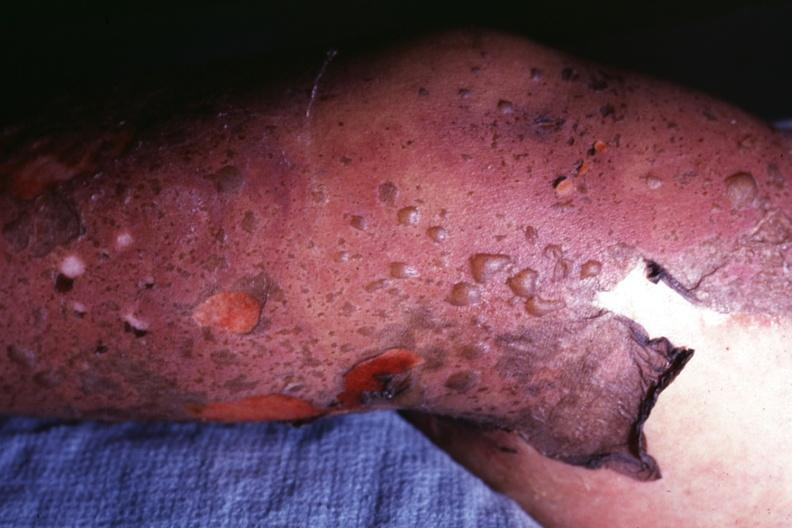what is sure what it looks like?
Answer the question using a single word or phrase. This 